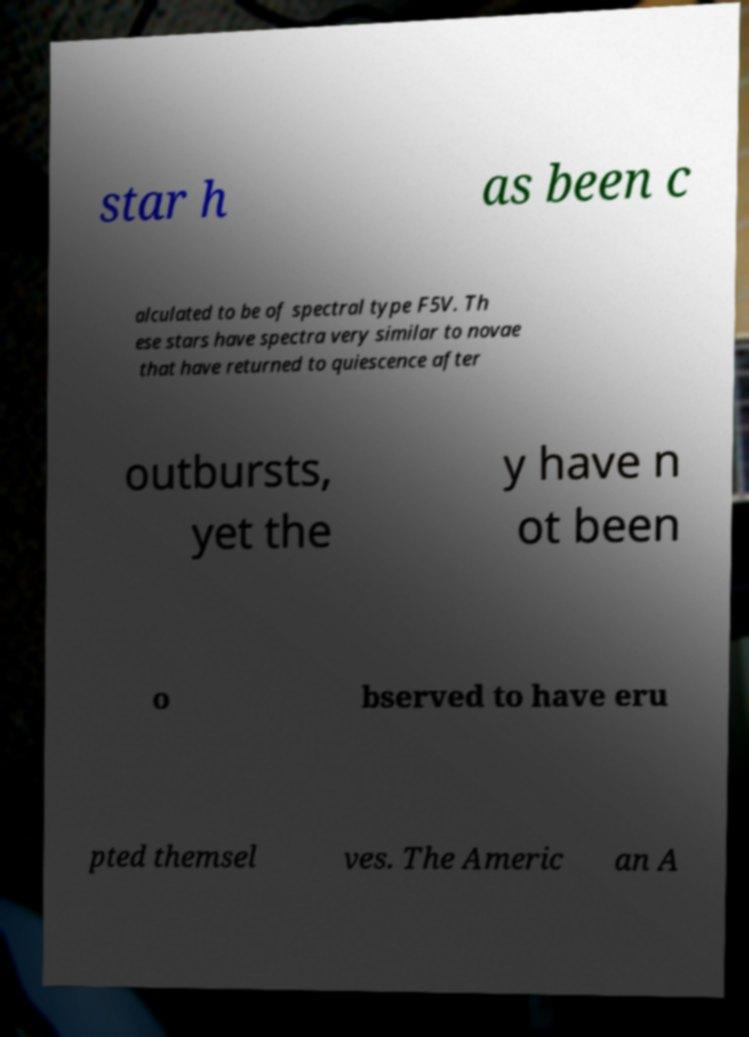What messages or text are displayed in this image? I need them in a readable, typed format. star h as been c alculated to be of spectral type F5V. Th ese stars have spectra very similar to novae that have returned to quiescence after outbursts, yet the y have n ot been o bserved to have eru pted themsel ves. The Americ an A 